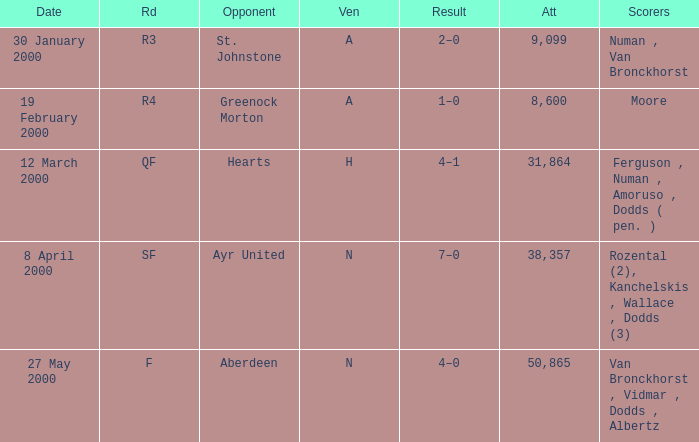Who was on 12 March 2000? Ferguson , Numan , Amoruso , Dodds ( pen. ). 